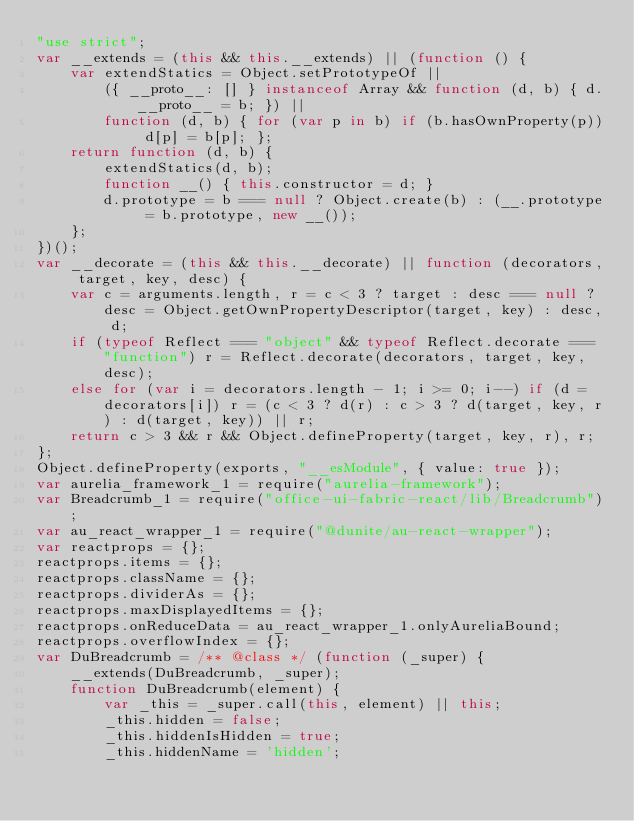<code> <loc_0><loc_0><loc_500><loc_500><_JavaScript_>"use strict";
var __extends = (this && this.__extends) || (function () {
    var extendStatics = Object.setPrototypeOf ||
        ({ __proto__: [] } instanceof Array && function (d, b) { d.__proto__ = b; }) ||
        function (d, b) { for (var p in b) if (b.hasOwnProperty(p)) d[p] = b[p]; };
    return function (d, b) {
        extendStatics(d, b);
        function __() { this.constructor = d; }
        d.prototype = b === null ? Object.create(b) : (__.prototype = b.prototype, new __());
    };
})();
var __decorate = (this && this.__decorate) || function (decorators, target, key, desc) {
    var c = arguments.length, r = c < 3 ? target : desc === null ? desc = Object.getOwnPropertyDescriptor(target, key) : desc, d;
    if (typeof Reflect === "object" && typeof Reflect.decorate === "function") r = Reflect.decorate(decorators, target, key, desc);
    else for (var i = decorators.length - 1; i >= 0; i--) if (d = decorators[i]) r = (c < 3 ? d(r) : c > 3 ? d(target, key, r) : d(target, key)) || r;
    return c > 3 && r && Object.defineProperty(target, key, r), r;
};
Object.defineProperty(exports, "__esModule", { value: true });
var aurelia_framework_1 = require("aurelia-framework");
var Breadcrumb_1 = require("office-ui-fabric-react/lib/Breadcrumb");
var au_react_wrapper_1 = require("@dunite/au-react-wrapper");
var reactprops = {};
reactprops.items = {};
reactprops.className = {};
reactprops.dividerAs = {};
reactprops.maxDisplayedItems = {};
reactprops.onReduceData = au_react_wrapper_1.onlyAureliaBound;
reactprops.overflowIndex = {};
var DuBreadcrumb = /** @class */ (function (_super) {
    __extends(DuBreadcrumb, _super);
    function DuBreadcrumb(element) {
        var _this = _super.call(this, element) || this;
        _this.hidden = false;
        _this.hiddenIsHidden = true;
        _this.hiddenName = 'hidden';</code> 